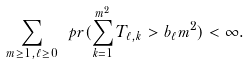Convert formula to latex. <formula><loc_0><loc_0><loc_500><loc_500>\sum _ { m \geq 1 , \ell \geq 0 } \ p r ( \sum _ { k = 1 } ^ { m ^ { 2 } } T _ { \ell , k } > b _ { \ell } m ^ { 2 } ) < \infty .</formula> 